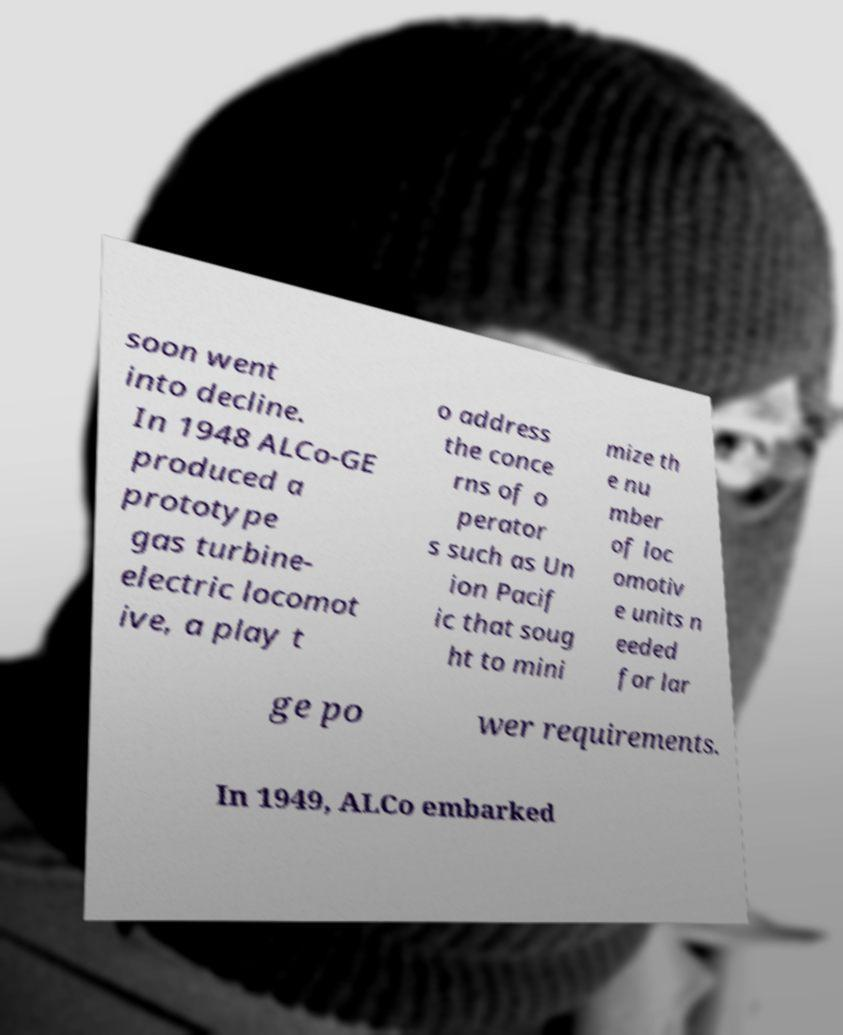Could you extract and type out the text from this image? soon went into decline. In 1948 ALCo-GE produced a prototype gas turbine- electric locomot ive, a play t o address the conce rns of o perator s such as Un ion Pacif ic that soug ht to mini mize th e nu mber of loc omotiv e units n eeded for lar ge po wer requirements. In 1949, ALCo embarked 